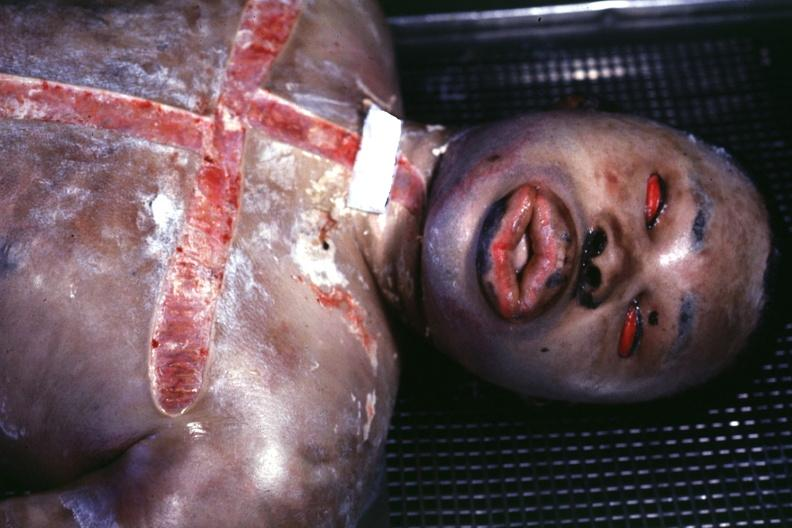what is present?
Answer the question using a single word or phrase. Edema due to disseminated intravascular coagulation 